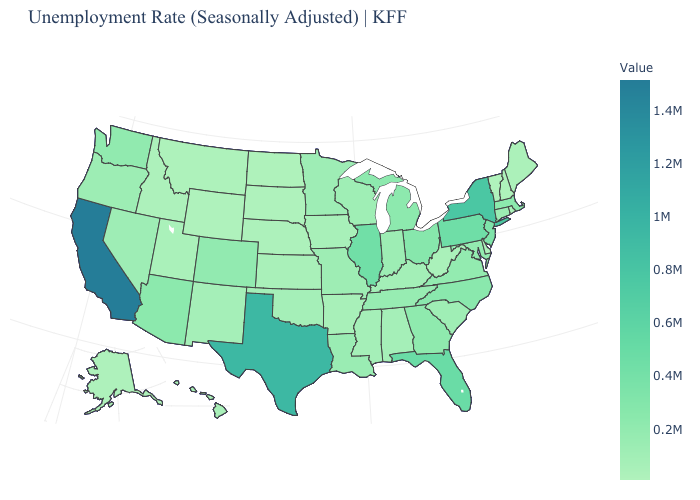Does the map have missing data?
Answer briefly. No. Does California have the highest value in the USA?
Quick response, please. Yes. Which states have the lowest value in the South?
Concise answer only. Delaware. Among the states that border Wyoming , does South Dakota have the highest value?
Short answer required. No. Which states have the highest value in the USA?
Write a very short answer. California. Which states have the highest value in the USA?
Answer briefly. California. 